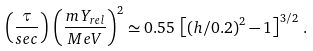<formula> <loc_0><loc_0><loc_500><loc_500>\left ( \frac { \tau } { s e c } \right ) \, \left ( \frac { m \, Y _ { r e l } } { M e V } \right ) ^ { 2 } \simeq 0 . 5 5 \, \left [ \left ( h / 0 . 2 \right ) ^ { 2 } - 1 \right ] ^ { 3 / 2 } \, .</formula> 